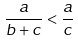<formula> <loc_0><loc_0><loc_500><loc_500>\frac { a } { b + c } < \frac { a } { c }</formula> 